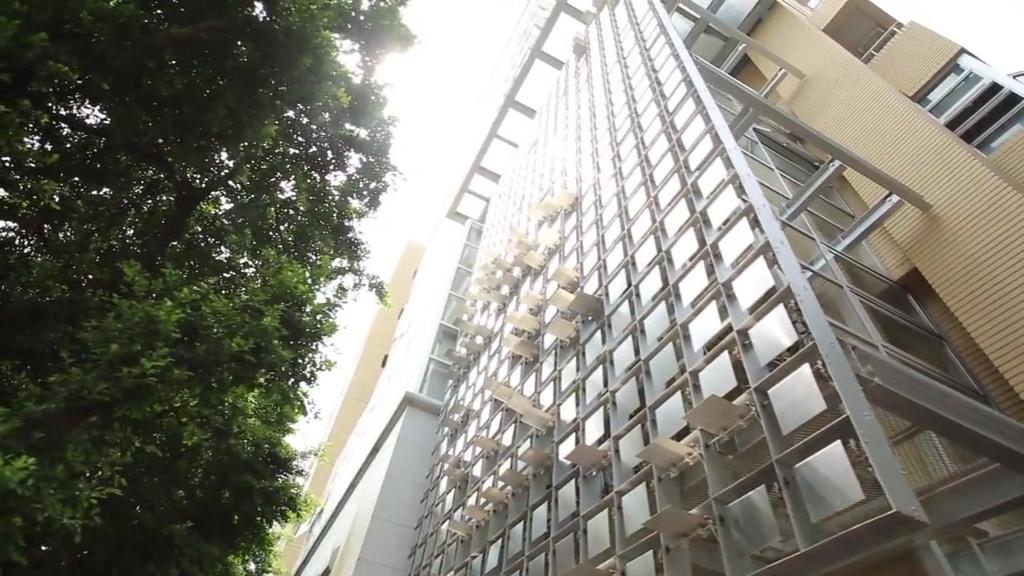What type of structure is visible in the image? There is a building in the image. What can be seen on the left side of the image? There is a tree on the left side of the image. What is visible at the top of the image? The sky is visible at the top of the image. What type of copper art can be seen on the roof of the building in the image? There is no copper art visible on the roof of the building in the image. How does the tree stretch towards the sky in the image? The tree does not stretch towards the sky in the image; it is stationary and not depicted as moving or stretching. 